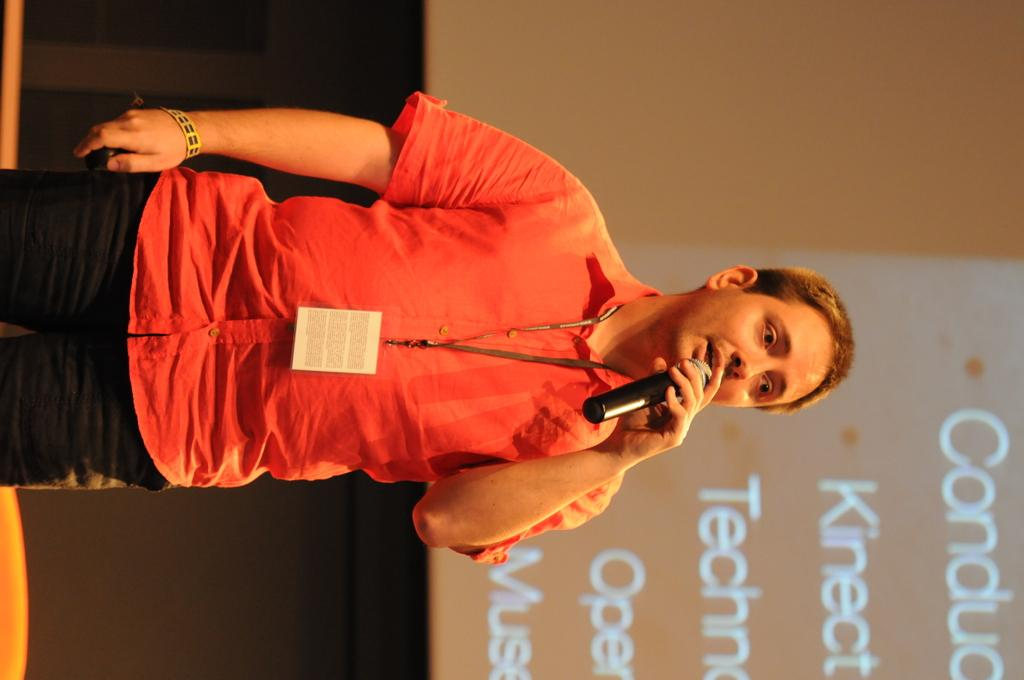Who or what is present in the image? There is a person in the image. What is the person holding in the image? The person is holding a microphone. What can be seen on the right side of the image? There is a screen on the right side of the image. What type of shoes is the person wearing in the image? There is no information about the person's shoes in the image, so we cannot determine what type they are wearing. 